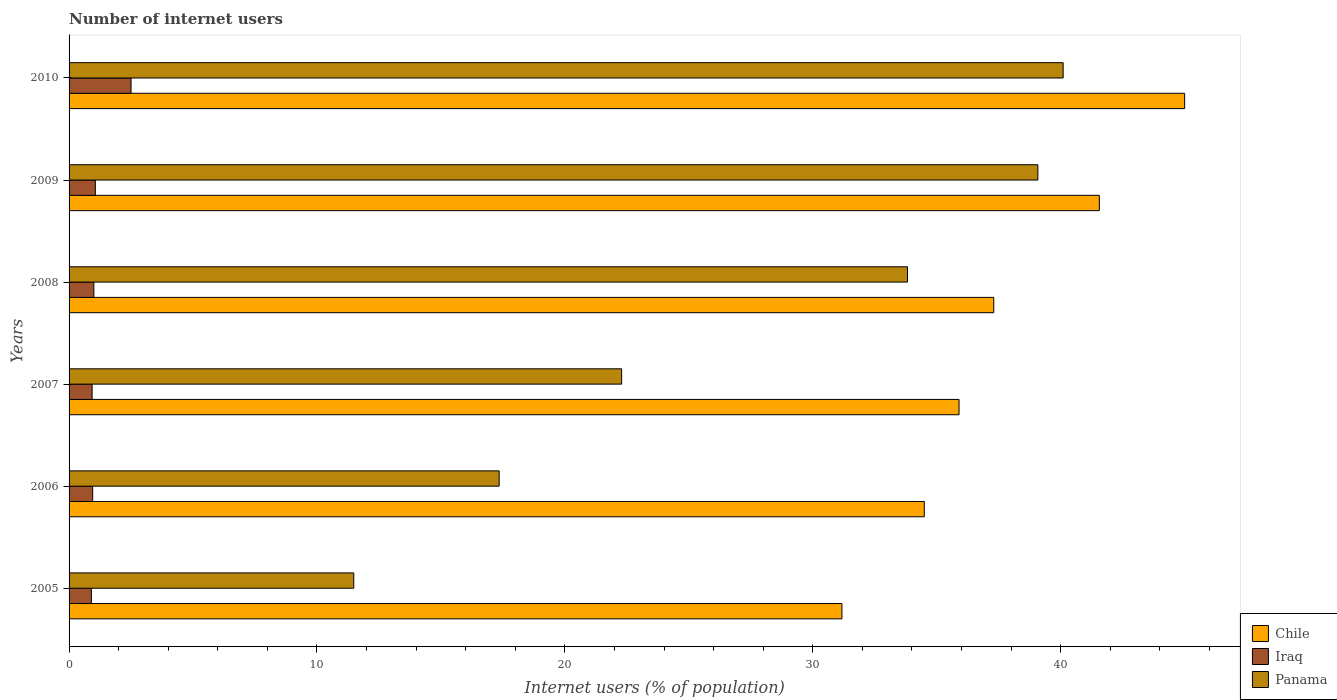How many different coloured bars are there?
Make the answer very short. 3. In how many cases, is the number of bars for a given year not equal to the number of legend labels?
Make the answer very short. 0. What is the number of internet users in Panama in 2008?
Your response must be concise. 33.82. Across all years, what is the minimum number of internet users in Iraq?
Make the answer very short. 0.9. In which year was the number of internet users in Iraq maximum?
Your answer should be very brief. 2010. What is the total number of internet users in Chile in the graph?
Make the answer very short. 225.43. What is the difference between the number of internet users in Panama in 2007 and that in 2008?
Keep it short and to the point. -11.53. What is the difference between the number of internet users in Iraq in 2006 and the number of internet users in Panama in 2010?
Your response must be concise. -39.15. What is the average number of internet users in Iraq per year?
Ensure brevity in your answer.  1.22. In the year 2006, what is the difference between the number of internet users in Chile and number of internet users in Iraq?
Provide a short and direct response. 33.55. In how many years, is the number of internet users in Iraq greater than 2 %?
Offer a very short reply. 1. What is the ratio of the number of internet users in Chile in 2008 to that in 2009?
Provide a short and direct response. 0.9. Is the number of internet users in Iraq in 2005 less than that in 2008?
Offer a very short reply. Yes. Is the difference between the number of internet users in Chile in 2008 and 2009 greater than the difference between the number of internet users in Iraq in 2008 and 2009?
Make the answer very short. No. What is the difference between the highest and the second highest number of internet users in Chile?
Your answer should be very brief. 3.44. What is the difference between the highest and the lowest number of internet users in Panama?
Give a very brief answer. 28.62. Is the sum of the number of internet users in Panama in 2005 and 2009 greater than the maximum number of internet users in Chile across all years?
Offer a terse response. Yes. What does the 3rd bar from the top in 2009 represents?
Provide a succinct answer. Chile. What does the 2nd bar from the bottom in 2009 represents?
Your answer should be very brief. Iraq. Is it the case that in every year, the sum of the number of internet users in Panama and number of internet users in Chile is greater than the number of internet users in Iraq?
Keep it short and to the point. Yes. Are all the bars in the graph horizontal?
Your answer should be compact. Yes. Are the values on the major ticks of X-axis written in scientific E-notation?
Offer a terse response. No. Does the graph contain any zero values?
Provide a short and direct response. No. How many legend labels are there?
Give a very brief answer. 3. How are the legend labels stacked?
Your answer should be very brief. Vertical. What is the title of the graph?
Ensure brevity in your answer.  Number of internet users. Does "Grenada" appear as one of the legend labels in the graph?
Provide a short and direct response. No. What is the label or title of the X-axis?
Provide a short and direct response. Internet users (% of population). What is the label or title of the Y-axis?
Your response must be concise. Years. What is the Internet users (% of population) of Chile in 2005?
Keep it short and to the point. 31.18. What is the Internet users (% of population) in Panama in 2005?
Offer a terse response. 11.48. What is the Internet users (% of population) of Chile in 2006?
Your answer should be compact. 34.5. What is the Internet users (% of population) of Iraq in 2006?
Provide a short and direct response. 0.95. What is the Internet users (% of population) of Panama in 2006?
Your answer should be very brief. 17.35. What is the Internet users (% of population) of Chile in 2007?
Provide a succinct answer. 35.9. What is the Internet users (% of population) of Panama in 2007?
Your answer should be compact. 22.29. What is the Internet users (% of population) in Chile in 2008?
Offer a terse response. 37.3. What is the Internet users (% of population) of Panama in 2008?
Offer a very short reply. 33.82. What is the Internet users (% of population) in Chile in 2009?
Provide a short and direct response. 41.56. What is the Internet users (% of population) in Iraq in 2009?
Your response must be concise. 1.06. What is the Internet users (% of population) in Panama in 2009?
Provide a short and direct response. 39.08. What is the Internet users (% of population) in Chile in 2010?
Make the answer very short. 45. What is the Internet users (% of population) of Iraq in 2010?
Offer a terse response. 2.5. What is the Internet users (% of population) of Panama in 2010?
Keep it short and to the point. 40.1. Across all years, what is the maximum Internet users (% of population) in Chile?
Your response must be concise. 45. Across all years, what is the maximum Internet users (% of population) of Panama?
Offer a very short reply. 40.1. Across all years, what is the minimum Internet users (% of population) of Chile?
Offer a terse response. 31.18. Across all years, what is the minimum Internet users (% of population) of Panama?
Give a very brief answer. 11.48. What is the total Internet users (% of population) in Chile in the graph?
Provide a short and direct response. 225.43. What is the total Internet users (% of population) of Iraq in the graph?
Offer a terse response. 7.34. What is the total Internet users (% of population) in Panama in the graph?
Give a very brief answer. 164.12. What is the difference between the Internet users (% of population) in Chile in 2005 and that in 2006?
Your answer should be very brief. -3.32. What is the difference between the Internet users (% of population) in Iraq in 2005 and that in 2006?
Provide a short and direct response. -0.05. What is the difference between the Internet users (% of population) of Panama in 2005 and that in 2006?
Offer a terse response. -5.87. What is the difference between the Internet users (% of population) in Chile in 2005 and that in 2007?
Your answer should be very brief. -4.72. What is the difference between the Internet users (% of population) in Iraq in 2005 and that in 2007?
Provide a short and direct response. -0.03. What is the difference between the Internet users (% of population) in Panama in 2005 and that in 2007?
Your answer should be compact. -10.81. What is the difference between the Internet users (% of population) of Chile in 2005 and that in 2008?
Give a very brief answer. -6.12. What is the difference between the Internet users (% of population) in Iraq in 2005 and that in 2008?
Offer a very short reply. -0.1. What is the difference between the Internet users (% of population) in Panama in 2005 and that in 2008?
Your answer should be compact. -22.34. What is the difference between the Internet users (% of population) in Chile in 2005 and that in 2009?
Keep it short and to the point. -10.38. What is the difference between the Internet users (% of population) in Iraq in 2005 and that in 2009?
Your response must be concise. -0.16. What is the difference between the Internet users (% of population) of Panama in 2005 and that in 2009?
Your answer should be very brief. -27.6. What is the difference between the Internet users (% of population) in Chile in 2005 and that in 2010?
Ensure brevity in your answer.  -13.82. What is the difference between the Internet users (% of population) in Iraq in 2005 and that in 2010?
Ensure brevity in your answer.  -1.6. What is the difference between the Internet users (% of population) of Panama in 2005 and that in 2010?
Keep it short and to the point. -28.62. What is the difference between the Internet users (% of population) of Chile in 2006 and that in 2007?
Keep it short and to the point. -1.4. What is the difference between the Internet users (% of population) of Iraq in 2006 and that in 2007?
Keep it short and to the point. 0.02. What is the difference between the Internet users (% of population) in Panama in 2006 and that in 2007?
Keep it short and to the point. -4.94. What is the difference between the Internet users (% of population) in Chile in 2006 and that in 2008?
Give a very brief answer. -2.8. What is the difference between the Internet users (% of population) in Iraq in 2006 and that in 2008?
Provide a short and direct response. -0.05. What is the difference between the Internet users (% of population) in Panama in 2006 and that in 2008?
Offer a very short reply. -16.47. What is the difference between the Internet users (% of population) of Chile in 2006 and that in 2009?
Make the answer very short. -7.06. What is the difference between the Internet users (% of population) of Iraq in 2006 and that in 2009?
Keep it short and to the point. -0.11. What is the difference between the Internet users (% of population) in Panama in 2006 and that in 2009?
Ensure brevity in your answer.  -21.73. What is the difference between the Internet users (% of population) of Chile in 2006 and that in 2010?
Your response must be concise. -10.5. What is the difference between the Internet users (% of population) in Iraq in 2006 and that in 2010?
Your response must be concise. -1.55. What is the difference between the Internet users (% of population) in Panama in 2006 and that in 2010?
Provide a short and direct response. -22.75. What is the difference between the Internet users (% of population) in Iraq in 2007 and that in 2008?
Offer a very short reply. -0.07. What is the difference between the Internet users (% of population) in Panama in 2007 and that in 2008?
Provide a short and direct response. -11.53. What is the difference between the Internet users (% of population) of Chile in 2007 and that in 2009?
Offer a very short reply. -5.66. What is the difference between the Internet users (% of population) of Iraq in 2007 and that in 2009?
Make the answer very short. -0.13. What is the difference between the Internet users (% of population) of Panama in 2007 and that in 2009?
Provide a short and direct response. -16.79. What is the difference between the Internet users (% of population) in Chile in 2007 and that in 2010?
Provide a short and direct response. -9.1. What is the difference between the Internet users (% of population) in Iraq in 2007 and that in 2010?
Your answer should be very brief. -1.57. What is the difference between the Internet users (% of population) in Panama in 2007 and that in 2010?
Ensure brevity in your answer.  -17.81. What is the difference between the Internet users (% of population) in Chile in 2008 and that in 2009?
Provide a short and direct response. -4.26. What is the difference between the Internet users (% of population) of Iraq in 2008 and that in 2009?
Your answer should be compact. -0.06. What is the difference between the Internet users (% of population) of Panama in 2008 and that in 2009?
Your answer should be very brief. -5.26. What is the difference between the Internet users (% of population) of Iraq in 2008 and that in 2010?
Your response must be concise. -1.5. What is the difference between the Internet users (% of population) in Panama in 2008 and that in 2010?
Your response must be concise. -6.28. What is the difference between the Internet users (% of population) of Chile in 2009 and that in 2010?
Your answer should be compact. -3.44. What is the difference between the Internet users (% of population) of Iraq in 2009 and that in 2010?
Provide a short and direct response. -1.44. What is the difference between the Internet users (% of population) in Panama in 2009 and that in 2010?
Provide a succinct answer. -1.02. What is the difference between the Internet users (% of population) of Chile in 2005 and the Internet users (% of population) of Iraq in 2006?
Provide a short and direct response. 30.22. What is the difference between the Internet users (% of population) of Chile in 2005 and the Internet users (% of population) of Panama in 2006?
Your answer should be very brief. 13.83. What is the difference between the Internet users (% of population) of Iraq in 2005 and the Internet users (% of population) of Panama in 2006?
Offer a terse response. -16.45. What is the difference between the Internet users (% of population) in Chile in 2005 and the Internet users (% of population) in Iraq in 2007?
Ensure brevity in your answer.  30.25. What is the difference between the Internet users (% of population) in Chile in 2005 and the Internet users (% of population) in Panama in 2007?
Ensure brevity in your answer.  8.89. What is the difference between the Internet users (% of population) in Iraq in 2005 and the Internet users (% of population) in Panama in 2007?
Give a very brief answer. -21.39. What is the difference between the Internet users (% of population) in Chile in 2005 and the Internet users (% of population) in Iraq in 2008?
Provide a succinct answer. 30.18. What is the difference between the Internet users (% of population) of Chile in 2005 and the Internet users (% of population) of Panama in 2008?
Give a very brief answer. -2.64. What is the difference between the Internet users (% of population) of Iraq in 2005 and the Internet users (% of population) of Panama in 2008?
Offer a very short reply. -32.92. What is the difference between the Internet users (% of population) in Chile in 2005 and the Internet users (% of population) in Iraq in 2009?
Provide a short and direct response. 30.12. What is the difference between the Internet users (% of population) in Chile in 2005 and the Internet users (% of population) in Panama in 2009?
Make the answer very short. -7.9. What is the difference between the Internet users (% of population) in Iraq in 2005 and the Internet users (% of population) in Panama in 2009?
Provide a succinct answer. -38.18. What is the difference between the Internet users (% of population) in Chile in 2005 and the Internet users (% of population) in Iraq in 2010?
Keep it short and to the point. 28.68. What is the difference between the Internet users (% of population) of Chile in 2005 and the Internet users (% of population) of Panama in 2010?
Your answer should be very brief. -8.92. What is the difference between the Internet users (% of population) in Iraq in 2005 and the Internet users (% of population) in Panama in 2010?
Ensure brevity in your answer.  -39.2. What is the difference between the Internet users (% of population) of Chile in 2006 and the Internet users (% of population) of Iraq in 2007?
Offer a terse response. 33.57. What is the difference between the Internet users (% of population) of Chile in 2006 and the Internet users (% of population) of Panama in 2007?
Give a very brief answer. 12.21. What is the difference between the Internet users (% of population) in Iraq in 2006 and the Internet users (% of population) in Panama in 2007?
Make the answer very short. -21.34. What is the difference between the Internet users (% of population) of Chile in 2006 and the Internet users (% of population) of Iraq in 2008?
Offer a terse response. 33.5. What is the difference between the Internet users (% of population) in Chile in 2006 and the Internet users (% of population) in Panama in 2008?
Give a very brief answer. 0.68. What is the difference between the Internet users (% of population) of Iraq in 2006 and the Internet users (% of population) of Panama in 2008?
Keep it short and to the point. -32.87. What is the difference between the Internet users (% of population) of Chile in 2006 and the Internet users (% of population) of Iraq in 2009?
Your answer should be very brief. 33.44. What is the difference between the Internet users (% of population) of Chile in 2006 and the Internet users (% of population) of Panama in 2009?
Ensure brevity in your answer.  -4.58. What is the difference between the Internet users (% of population) in Iraq in 2006 and the Internet users (% of population) in Panama in 2009?
Make the answer very short. -38.13. What is the difference between the Internet users (% of population) of Chile in 2006 and the Internet users (% of population) of Iraq in 2010?
Your response must be concise. 32. What is the difference between the Internet users (% of population) in Chile in 2006 and the Internet users (% of population) in Panama in 2010?
Provide a succinct answer. -5.6. What is the difference between the Internet users (% of population) of Iraq in 2006 and the Internet users (% of population) of Panama in 2010?
Your answer should be compact. -39.15. What is the difference between the Internet users (% of population) in Chile in 2007 and the Internet users (% of population) in Iraq in 2008?
Keep it short and to the point. 34.9. What is the difference between the Internet users (% of population) in Chile in 2007 and the Internet users (% of population) in Panama in 2008?
Your answer should be very brief. 2.08. What is the difference between the Internet users (% of population) in Iraq in 2007 and the Internet users (% of population) in Panama in 2008?
Provide a short and direct response. -32.89. What is the difference between the Internet users (% of population) of Chile in 2007 and the Internet users (% of population) of Iraq in 2009?
Give a very brief answer. 34.84. What is the difference between the Internet users (% of population) in Chile in 2007 and the Internet users (% of population) in Panama in 2009?
Provide a short and direct response. -3.18. What is the difference between the Internet users (% of population) in Iraq in 2007 and the Internet users (% of population) in Panama in 2009?
Make the answer very short. -38.15. What is the difference between the Internet users (% of population) in Chile in 2007 and the Internet users (% of population) in Iraq in 2010?
Keep it short and to the point. 33.4. What is the difference between the Internet users (% of population) in Chile in 2007 and the Internet users (% of population) in Panama in 2010?
Offer a terse response. -4.2. What is the difference between the Internet users (% of population) of Iraq in 2007 and the Internet users (% of population) of Panama in 2010?
Offer a terse response. -39.17. What is the difference between the Internet users (% of population) of Chile in 2008 and the Internet users (% of population) of Iraq in 2009?
Make the answer very short. 36.24. What is the difference between the Internet users (% of population) of Chile in 2008 and the Internet users (% of population) of Panama in 2009?
Ensure brevity in your answer.  -1.78. What is the difference between the Internet users (% of population) in Iraq in 2008 and the Internet users (% of population) in Panama in 2009?
Offer a very short reply. -38.08. What is the difference between the Internet users (% of population) of Chile in 2008 and the Internet users (% of population) of Iraq in 2010?
Your answer should be very brief. 34.8. What is the difference between the Internet users (% of population) in Chile in 2008 and the Internet users (% of population) in Panama in 2010?
Offer a very short reply. -2.8. What is the difference between the Internet users (% of population) of Iraq in 2008 and the Internet users (% of population) of Panama in 2010?
Your response must be concise. -39.1. What is the difference between the Internet users (% of population) of Chile in 2009 and the Internet users (% of population) of Iraq in 2010?
Your answer should be very brief. 39.06. What is the difference between the Internet users (% of population) in Chile in 2009 and the Internet users (% of population) in Panama in 2010?
Offer a terse response. 1.46. What is the difference between the Internet users (% of population) of Iraq in 2009 and the Internet users (% of population) of Panama in 2010?
Offer a very short reply. -39.04. What is the average Internet users (% of population) in Chile per year?
Offer a terse response. 37.57. What is the average Internet users (% of population) in Iraq per year?
Offer a terse response. 1.22. What is the average Internet users (% of population) in Panama per year?
Offer a very short reply. 27.35. In the year 2005, what is the difference between the Internet users (% of population) in Chile and Internet users (% of population) in Iraq?
Your answer should be compact. 30.28. In the year 2005, what is the difference between the Internet users (% of population) in Chile and Internet users (% of population) in Panama?
Make the answer very short. 19.69. In the year 2005, what is the difference between the Internet users (% of population) in Iraq and Internet users (% of population) in Panama?
Provide a short and direct response. -10.58. In the year 2006, what is the difference between the Internet users (% of population) in Chile and Internet users (% of population) in Iraq?
Your answer should be very brief. 33.55. In the year 2006, what is the difference between the Internet users (% of population) in Chile and Internet users (% of population) in Panama?
Give a very brief answer. 17.15. In the year 2006, what is the difference between the Internet users (% of population) of Iraq and Internet users (% of population) of Panama?
Your response must be concise. -16.4. In the year 2007, what is the difference between the Internet users (% of population) of Chile and Internet users (% of population) of Iraq?
Keep it short and to the point. 34.97. In the year 2007, what is the difference between the Internet users (% of population) in Chile and Internet users (% of population) in Panama?
Provide a short and direct response. 13.61. In the year 2007, what is the difference between the Internet users (% of population) of Iraq and Internet users (% of population) of Panama?
Your response must be concise. -21.36. In the year 2008, what is the difference between the Internet users (% of population) in Chile and Internet users (% of population) in Iraq?
Your response must be concise. 36.3. In the year 2008, what is the difference between the Internet users (% of population) of Chile and Internet users (% of population) of Panama?
Offer a terse response. 3.48. In the year 2008, what is the difference between the Internet users (% of population) of Iraq and Internet users (% of population) of Panama?
Provide a short and direct response. -32.82. In the year 2009, what is the difference between the Internet users (% of population) in Chile and Internet users (% of population) in Iraq?
Make the answer very short. 40.5. In the year 2009, what is the difference between the Internet users (% of population) in Chile and Internet users (% of population) in Panama?
Ensure brevity in your answer.  2.48. In the year 2009, what is the difference between the Internet users (% of population) of Iraq and Internet users (% of population) of Panama?
Ensure brevity in your answer.  -38.02. In the year 2010, what is the difference between the Internet users (% of population) of Chile and Internet users (% of population) of Iraq?
Provide a succinct answer. 42.5. In the year 2010, what is the difference between the Internet users (% of population) in Iraq and Internet users (% of population) in Panama?
Your answer should be compact. -37.6. What is the ratio of the Internet users (% of population) of Chile in 2005 to that in 2006?
Offer a terse response. 0.9. What is the ratio of the Internet users (% of population) of Iraq in 2005 to that in 2006?
Keep it short and to the point. 0.94. What is the ratio of the Internet users (% of population) of Panama in 2005 to that in 2006?
Provide a succinct answer. 0.66. What is the ratio of the Internet users (% of population) of Chile in 2005 to that in 2007?
Offer a very short reply. 0.87. What is the ratio of the Internet users (% of population) in Panama in 2005 to that in 2007?
Offer a very short reply. 0.52. What is the ratio of the Internet users (% of population) in Chile in 2005 to that in 2008?
Your response must be concise. 0.84. What is the ratio of the Internet users (% of population) in Panama in 2005 to that in 2008?
Offer a very short reply. 0.34. What is the ratio of the Internet users (% of population) in Chile in 2005 to that in 2009?
Give a very brief answer. 0.75. What is the ratio of the Internet users (% of population) of Iraq in 2005 to that in 2009?
Offer a very short reply. 0.85. What is the ratio of the Internet users (% of population) in Panama in 2005 to that in 2009?
Offer a very short reply. 0.29. What is the ratio of the Internet users (% of population) in Chile in 2005 to that in 2010?
Give a very brief answer. 0.69. What is the ratio of the Internet users (% of population) in Iraq in 2005 to that in 2010?
Your answer should be compact. 0.36. What is the ratio of the Internet users (% of population) of Panama in 2005 to that in 2010?
Your response must be concise. 0.29. What is the ratio of the Internet users (% of population) in Chile in 2006 to that in 2007?
Make the answer very short. 0.96. What is the ratio of the Internet users (% of population) in Panama in 2006 to that in 2007?
Ensure brevity in your answer.  0.78. What is the ratio of the Internet users (% of population) in Chile in 2006 to that in 2008?
Your answer should be compact. 0.92. What is the ratio of the Internet users (% of population) in Iraq in 2006 to that in 2008?
Offer a very short reply. 0.95. What is the ratio of the Internet users (% of population) of Panama in 2006 to that in 2008?
Your response must be concise. 0.51. What is the ratio of the Internet users (% of population) in Chile in 2006 to that in 2009?
Offer a terse response. 0.83. What is the ratio of the Internet users (% of population) in Iraq in 2006 to that in 2009?
Give a very brief answer. 0.9. What is the ratio of the Internet users (% of population) of Panama in 2006 to that in 2009?
Keep it short and to the point. 0.44. What is the ratio of the Internet users (% of population) of Chile in 2006 to that in 2010?
Keep it short and to the point. 0.77. What is the ratio of the Internet users (% of population) of Iraq in 2006 to that in 2010?
Make the answer very short. 0.38. What is the ratio of the Internet users (% of population) of Panama in 2006 to that in 2010?
Keep it short and to the point. 0.43. What is the ratio of the Internet users (% of population) of Chile in 2007 to that in 2008?
Provide a short and direct response. 0.96. What is the ratio of the Internet users (% of population) of Iraq in 2007 to that in 2008?
Offer a terse response. 0.93. What is the ratio of the Internet users (% of population) of Panama in 2007 to that in 2008?
Ensure brevity in your answer.  0.66. What is the ratio of the Internet users (% of population) in Chile in 2007 to that in 2009?
Give a very brief answer. 0.86. What is the ratio of the Internet users (% of population) in Iraq in 2007 to that in 2009?
Your response must be concise. 0.88. What is the ratio of the Internet users (% of population) in Panama in 2007 to that in 2009?
Offer a terse response. 0.57. What is the ratio of the Internet users (% of population) of Chile in 2007 to that in 2010?
Make the answer very short. 0.8. What is the ratio of the Internet users (% of population) in Iraq in 2007 to that in 2010?
Provide a succinct answer. 0.37. What is the ratio of the Internet users (% of population) in Panama in 2007 to that in 2010?
Your answer should be very brief. 0.56. What is the ratio of the Internet users (% of population) in Chile in 2008 to that in 2009?
Your answer should be compact. 0.9. What is the ratio of the Internet users (% of population) of Iraq in 2008 to that in 2009?
Offer a terse response. 0.94. What is the ratio of the Internet users (% of population) of Panama in 2008 to that in 2009?
Offer a terse response. 0.87. What is the ratio of the Internet users (% of population) of Chile in 2008 to that in 2010?
Offer a terse response. 0.83. What is the ratio of the Internet users (% of population) in Panama in 2008 to that in 2010?
Offer a terse response. 0.84. What is the ratio of the Internet users (% of population) in Chile in 2009 to that in 2010?
Offer a terse response. 0.92. What is the ratio of the Internet users (% of population) in Iraq in 2009 to that in 2010?
Make the answer very short. 0.42. What is the ratio of the Internet users (% of population) in Panama in 2009 to that in 2010?
Make the answer very short. 0.97. What is the difference between the highest and the second highest Internet users (% of population) in Chile?
Your answer should be very brief. 3.44. What is the difference between the highest and the second highest Internet users (% of population) of Iraq?
Your answer should be compact. 1.44. What is the difference between the highest and the lowest Internet users (% of population) in Chile?
Keep it short and to the point. 13.82. What is the difference between the highest and the lowest Internet users (% of population) of Panama?
Your answer should be compact. 28.62. 